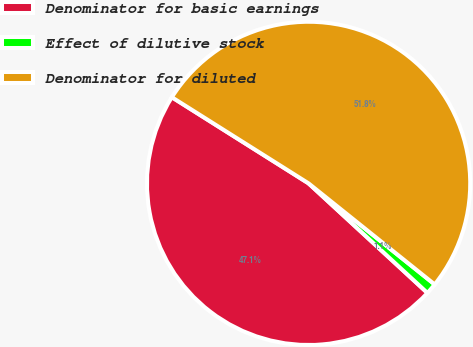<chart> <loc_0><loc_0><loc_500><loc_500><pie_chart><fcel>Denominator for basic earnings<fcel>Effect of dilutive stock<fcel>Denominator for diluted<nl><fcel>47.09%<fcel>1.1%<fcel>51.8%<nl></chart> 